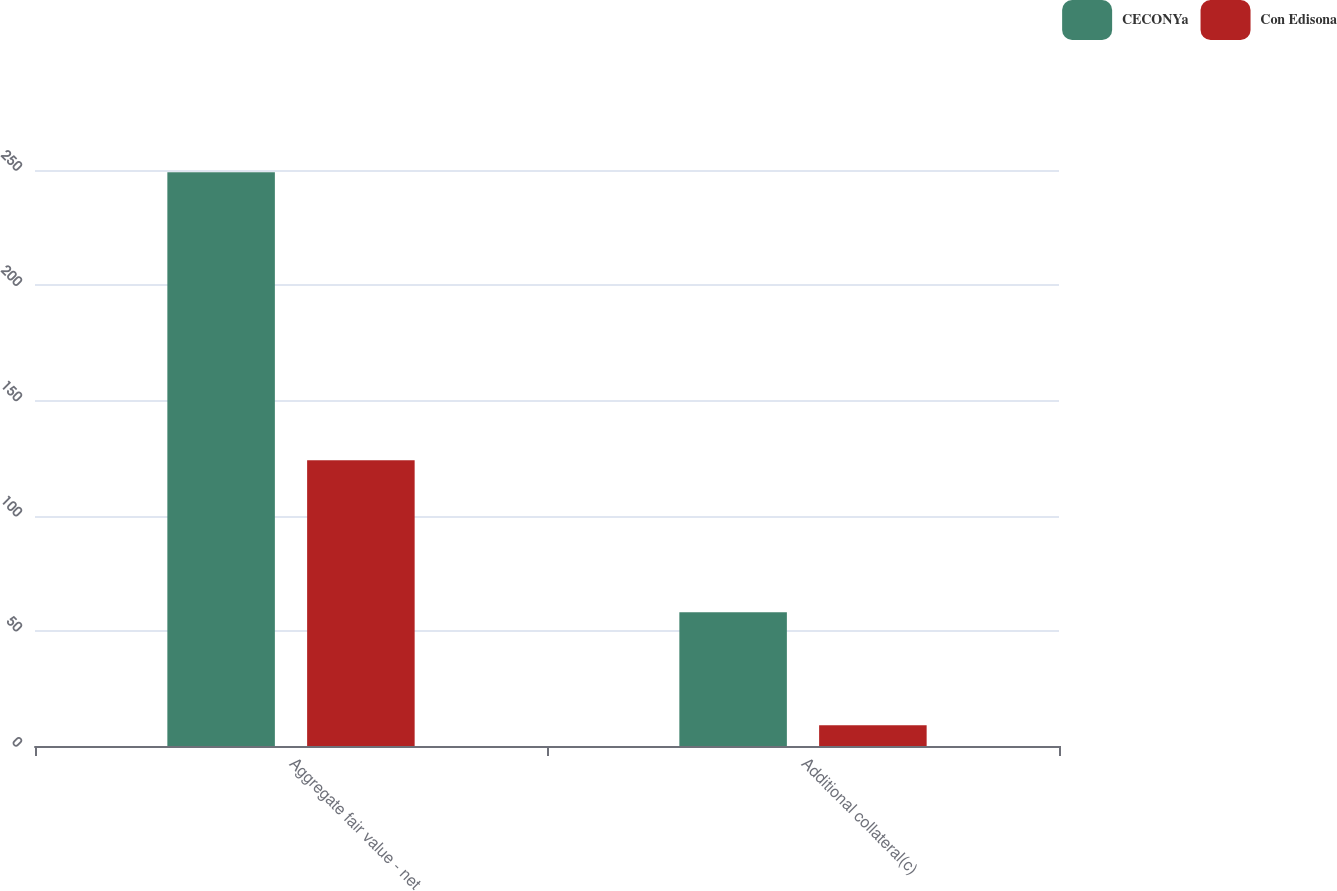<chart> <loc_0><loc_0><loc_500><loc_500><stacked_bar_chart><ecel><fcel>Aggregate fair value - net<fcel>Additional collateral(c)<nl><fcel>CECONYa<fcel>249<fcel>58<nl><fcel>Con Edisona<fcel>124<fcel>9<nl></chart> 